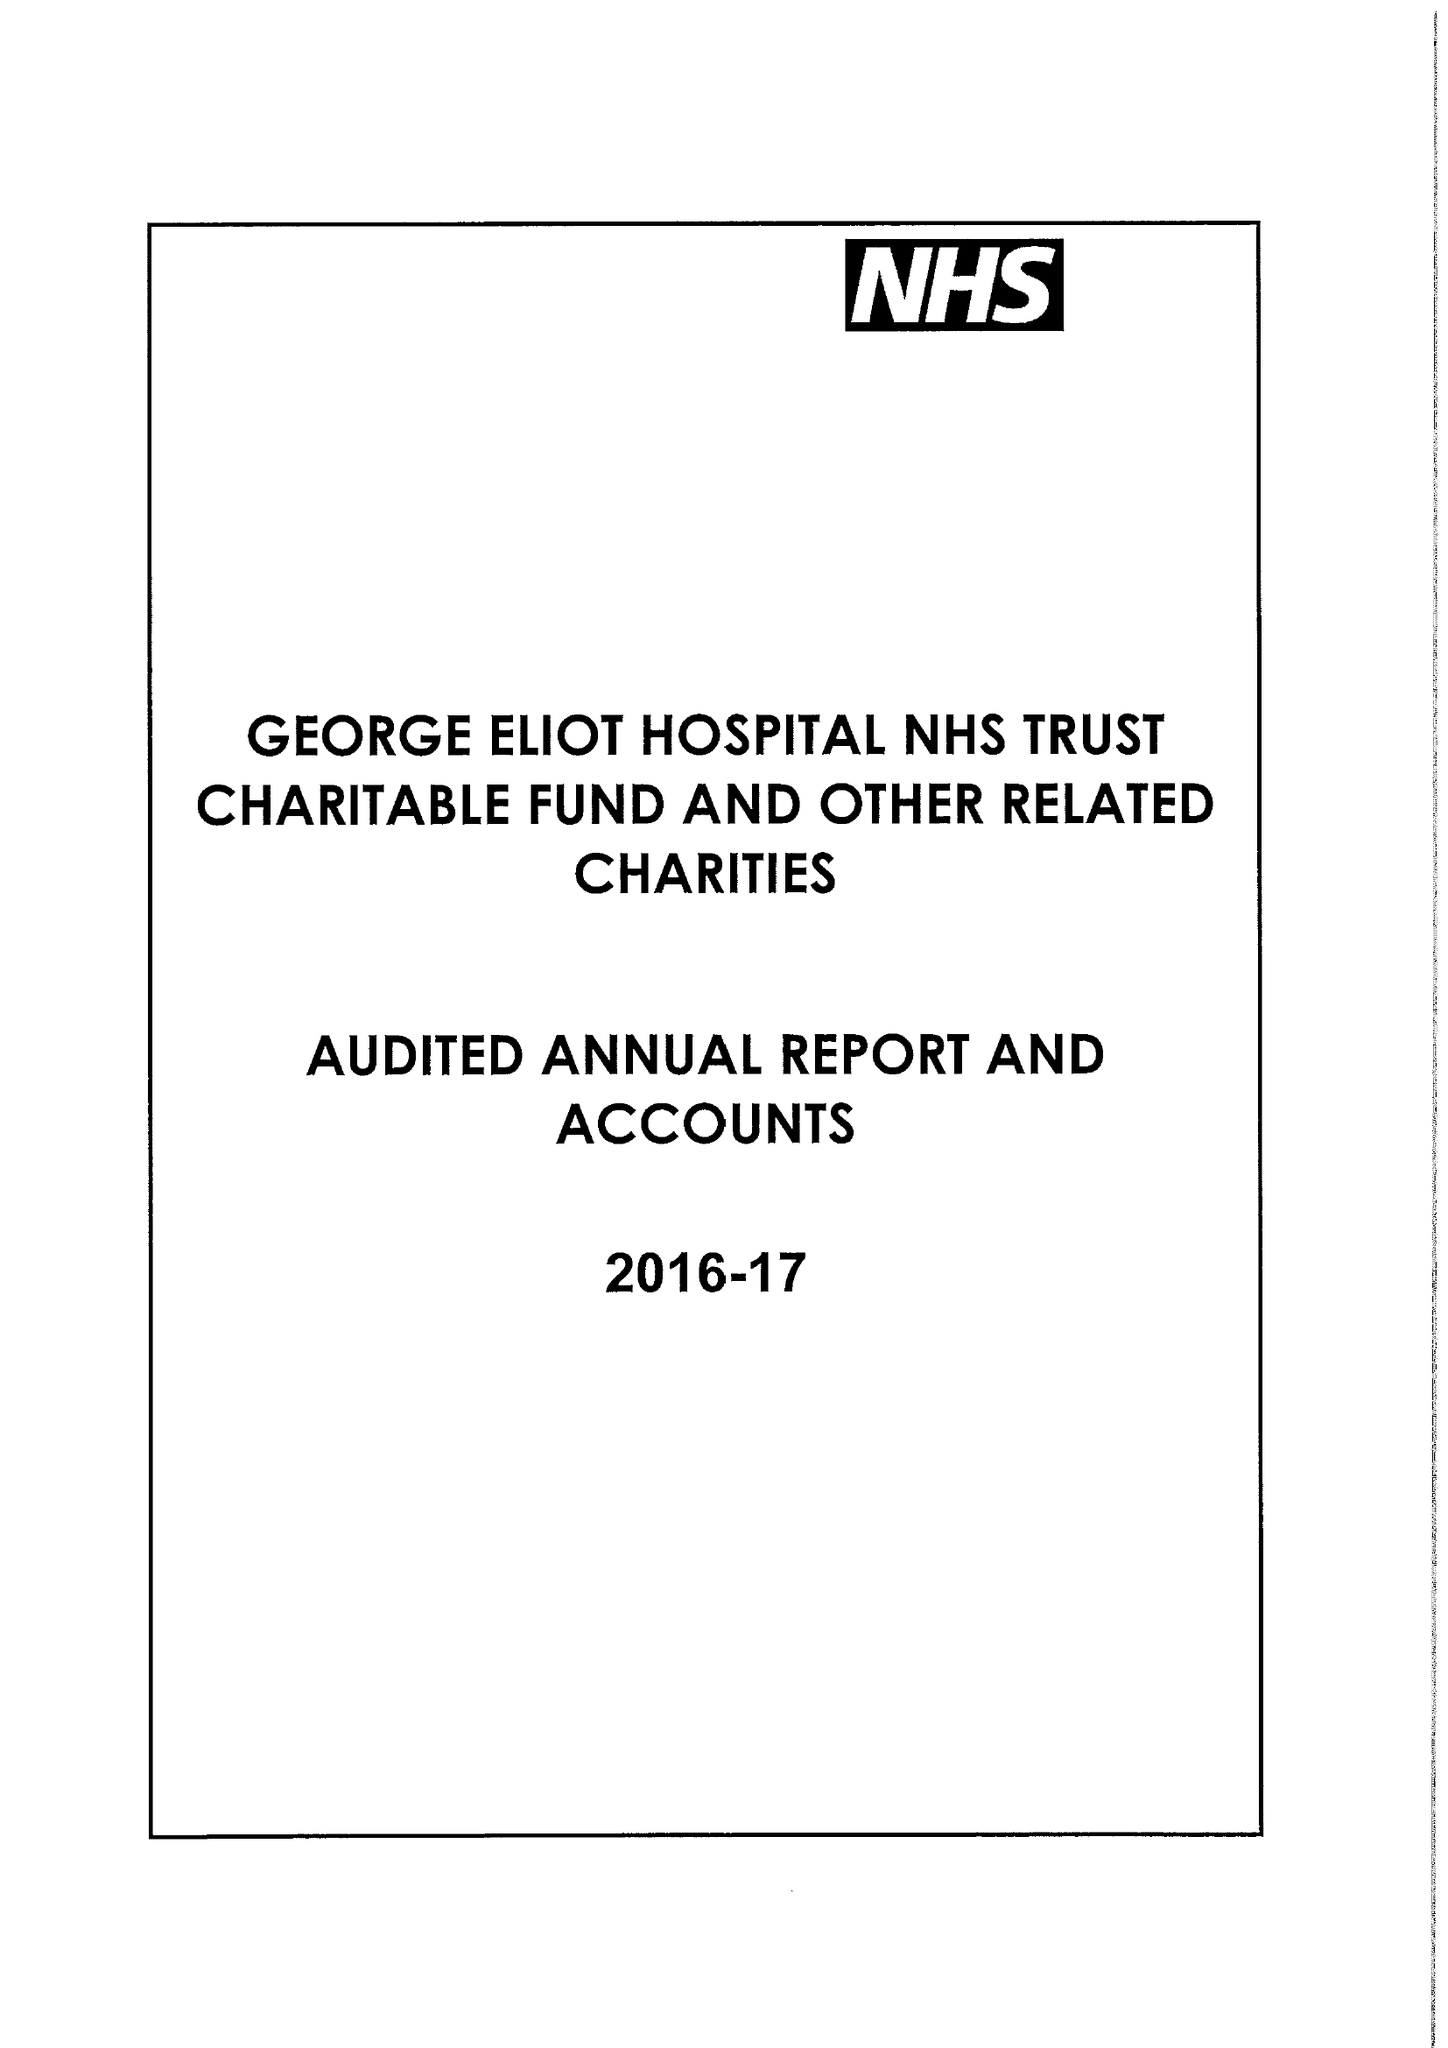What is the value for the income_annually_in_british_pounds?
Answer the question using a single word or phrase. 181000.00 